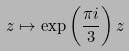<formula> <loc_0><loc_0><loc_500><loc_500>z \mapsto \exp \left ( \frac { \pi i } { 3 } \right ) z</formula> 